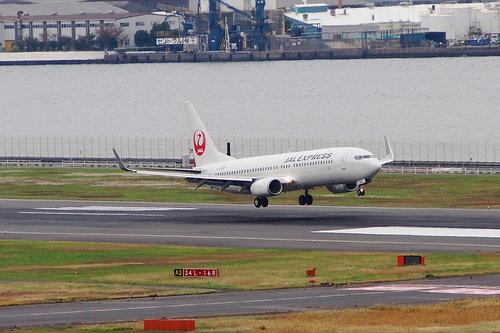Question: what is the plane doing?
Choices:
A. Flying.
B. Coasting.
C. Landing.
D. Crashing.
Answer with the letter. Answer: C Question: why are the wheels down?
Choices:
A. To get over the hump.
B. To meet the road.
C. To show off.
D. So the plane can land.
Answer with the letter. Answer: D Question: who drives a vehicle like this?
Choices:
A. A pilot.
B. A bus driver.
C. A cabbie.
D. Your mom.
Answer with the letter. Answer: A Question: what color is the plane's body?
Choices:
A. Blue.
B. White.
C. Orange.
D. Yellow.
Answer with the letter. Answer: B 